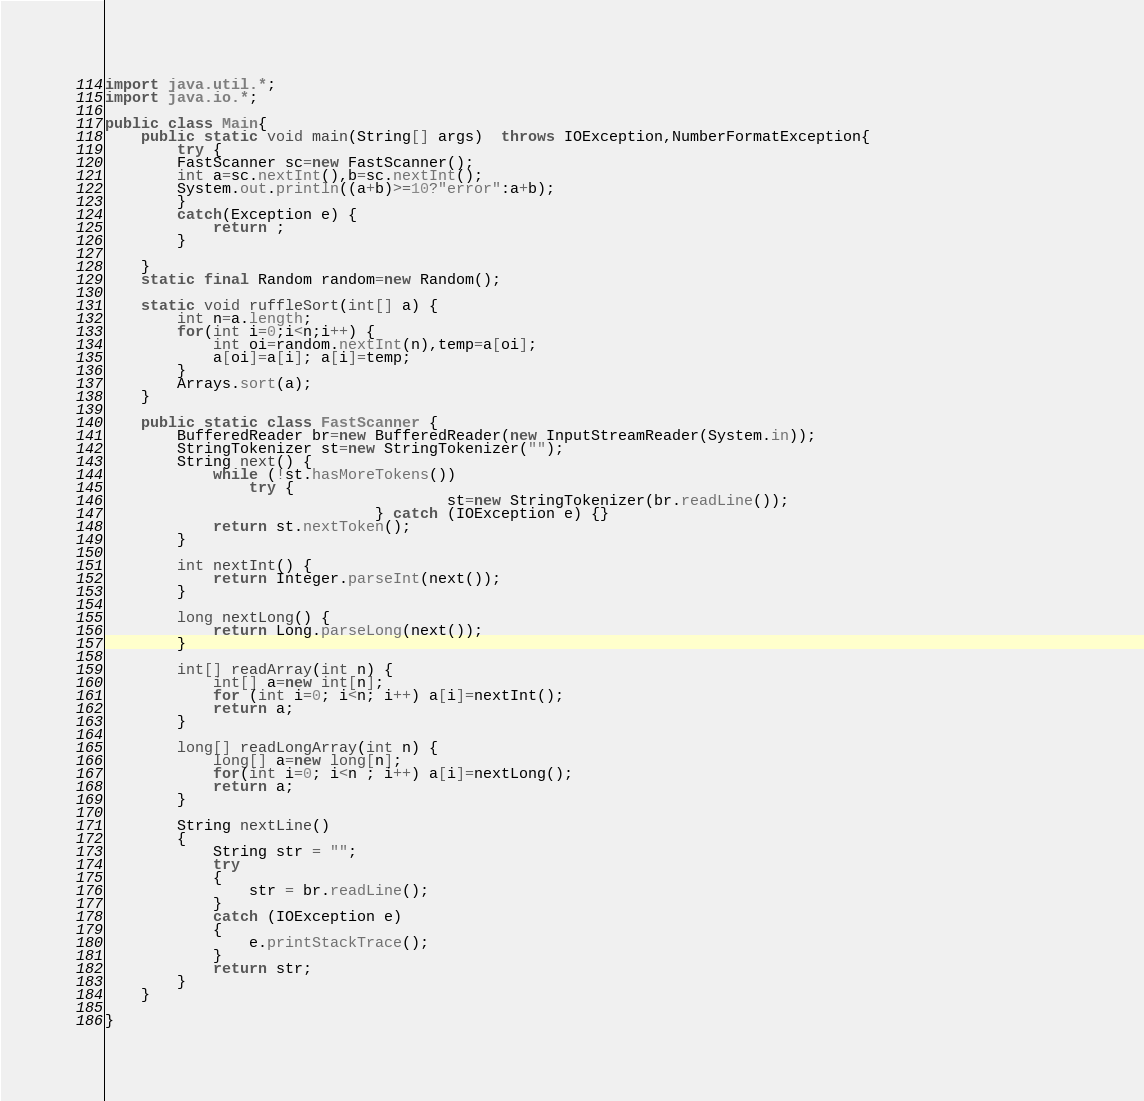<code> <loc_0><loc_0><loc_500><loc_500><_Java_>
import java.util.*;
import java.io.*;

public class Main{
	public static void main(String[] args)  throws IOException,NumberFormatException{
		try {
		FastScanner sc=new FastScanner();
		int a=sc.nextInt(),b=sc.nextInt();
		System.out.println((a+b)>=10?"error":a+b);
		}
		catch(Exception e) {
			return ;
		}
		
	}
	static final Random random=new Random();
	
	static void ruffleSort(int[] a) {
		int n=a.length;
		for(int i=0;i<n;i++) {
			int oi=random.nextInt(n),temp=a[oi];
			a[oi]=a[i]; a[i]=temp;
		}
		Arrays.sort(a);
	}
	
	public static class FastScanner {
		BufferedReader br=new BufferedReader(new InputStreamReader(System.in));
		StringTokenizer st=new StringTokenizer("");
		String next() {
			while (!st.hasMoreTokens())
				try { 
                                      st=new StringTokenizer(br.readLine());				               
                              } catch (IOException e) {}
			return st.nextToken();
		}
		
		int nextInt() {
			return Integer.parseInt(next());
		}
		
		long nextLong() {
			return Long.parseLong(next());
		}
		
		int[] readArray(int n) {
			int[] a=new int[n];
			for (int i=0; i<n; i++) a[i]=nextInt();
			return a;
		}
		
		long[] readLongArray(int n) {
			long[] a=new long[n];
			for(int i=0; i<n ; i++) a[i]=nextLong();
			return a;
		}
		
		String nextLine() 
        { 
            String str = ""; 
            try
            { 
                str = br.readLine(); 
            } 
            catch (IOException e) 
            { 
                e.printStackTrace(); 
            } 
            return str; 
        } 
	}

}
</code> 